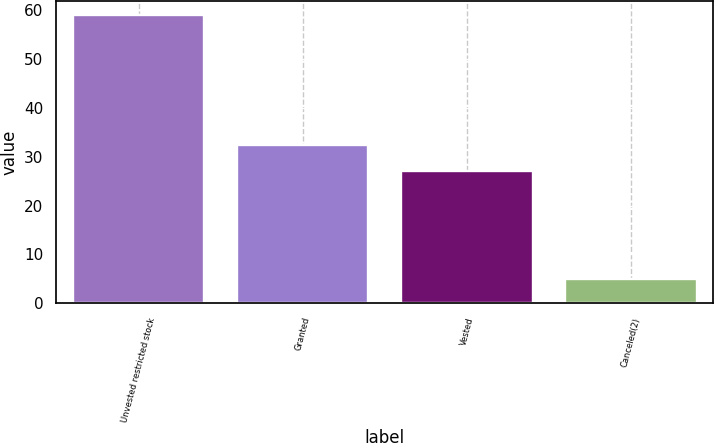Convert chart. <chart><loc_0><loc_0><loc_500><loc_500><bar_chart><fcel>Unvested restricted stock<fcel>Granted<fcel>Vested<fcel>Canceled(2)<nl><fcel>59<fcel>32.5<fcel>27<fcel>5<nl></chart> 